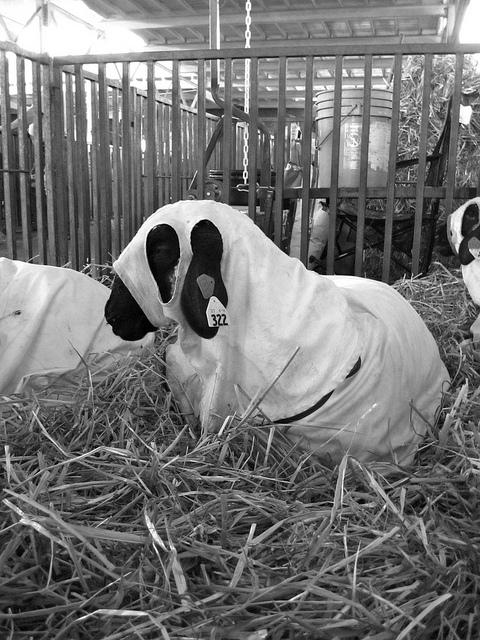The first digit of the number that is clipped to the ear is included in what number? three 